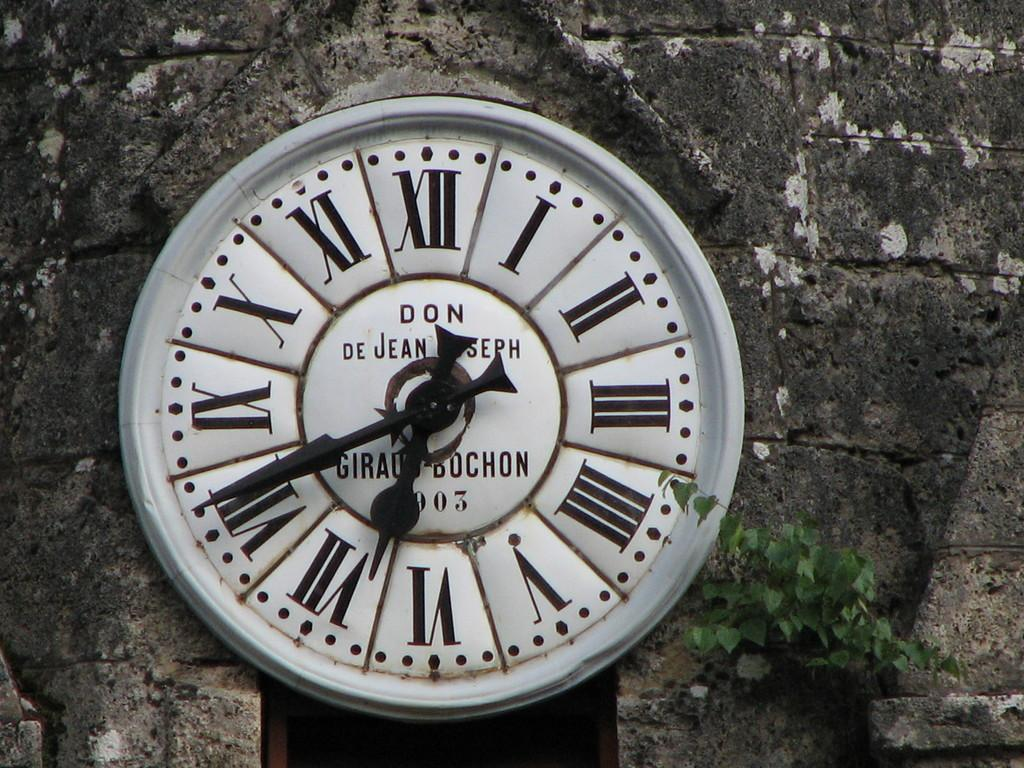Provide a one-sentence caption for the provided image. A clock with Roman numerals pointing to twenty to seven. 